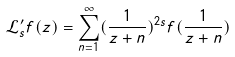<formula> <loc_0><loc_0><loc_500><loc_500>\mathcal { L } ^ { \prime } _ { s } f ( z ) = \sum _ { n = 1 } ^ { \infty } ( \frac { 1 } { z + n } ) ^ { 2 s } f ( \frac { 1 } { z + n } )</formula> 